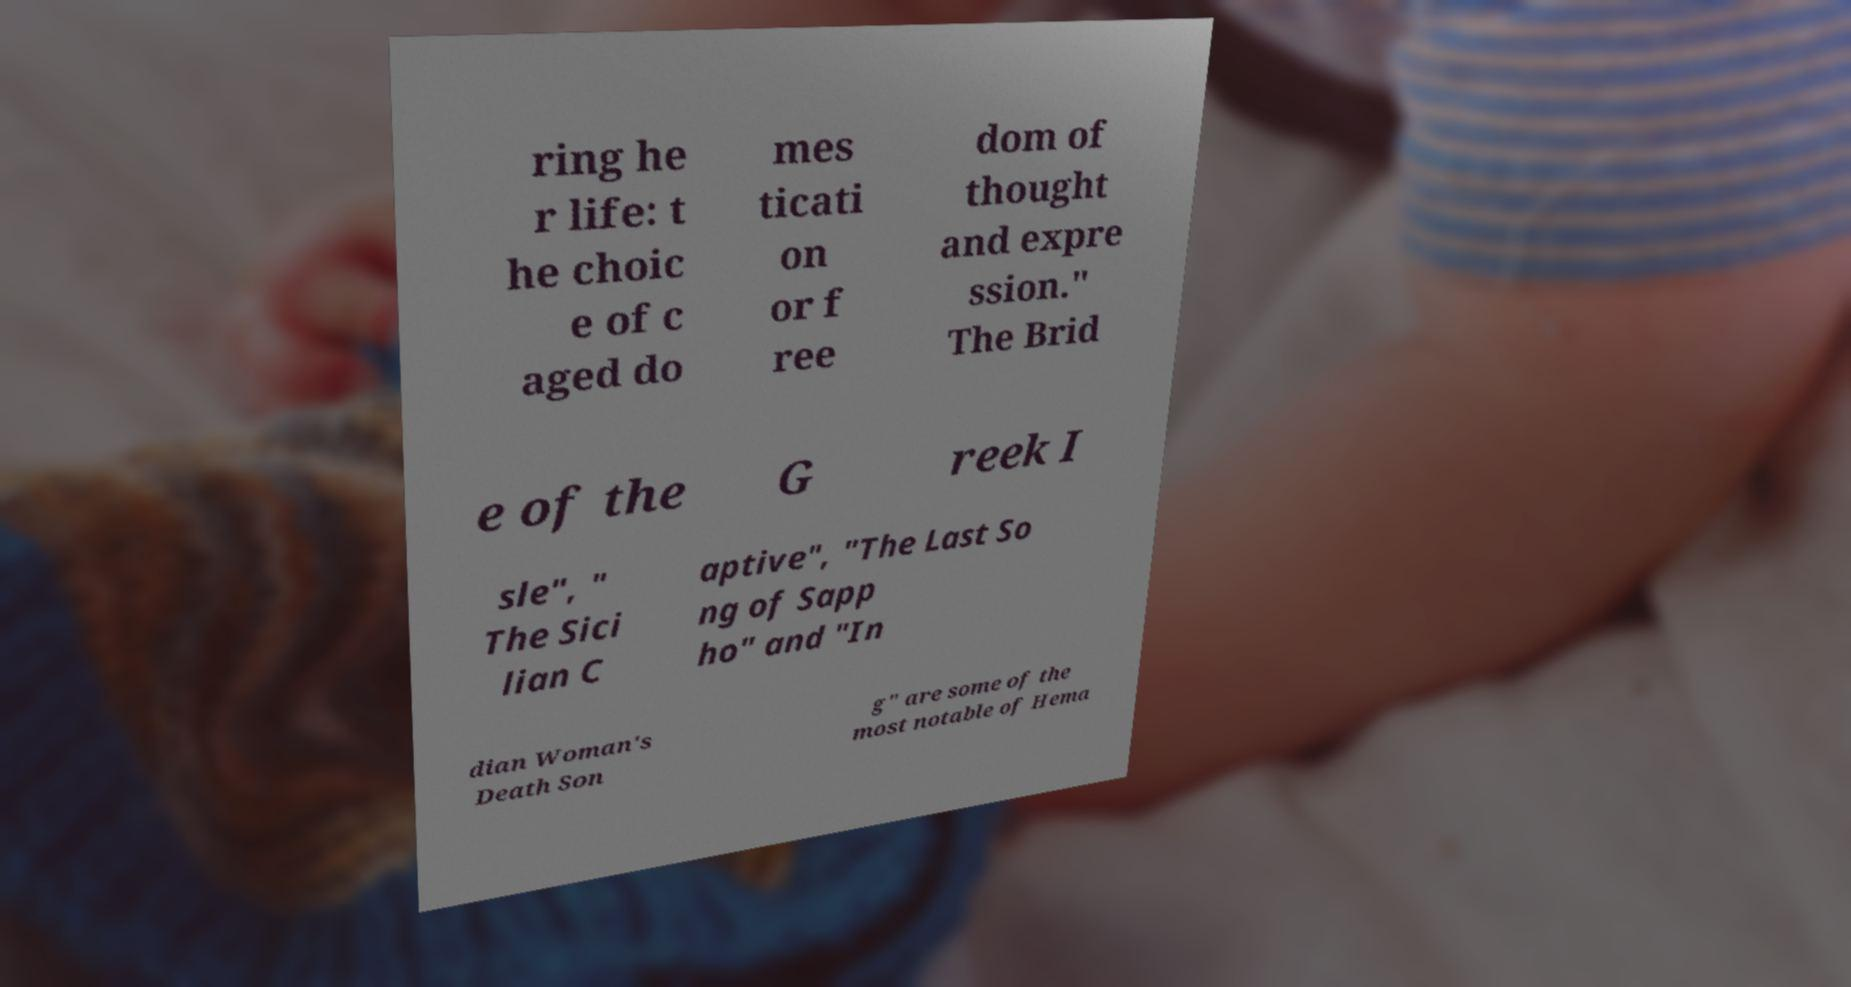Please identify and transcribe the text found in this image. ring he r life: t he choic e of c aged do mes ticati on or f ree dom of thought and expre ssion." The Brid e of the G reek I sle", " The Sici lian C aptive", "The Last So ng of Sapp ho" and "In dian Woman's Death Son g" are some of the most notable of Hema 